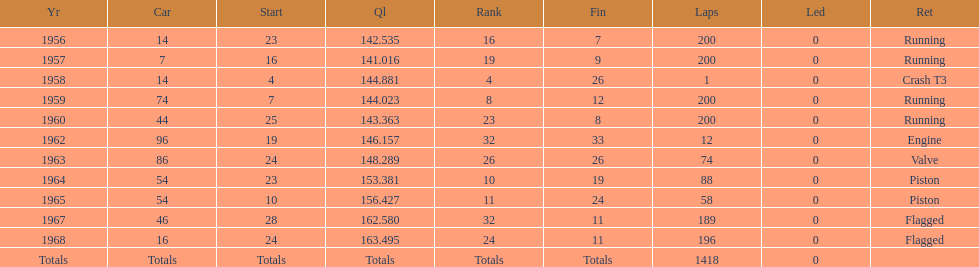What was its best starting position? 4. Give me the full table as a dictionary. {'header': ['Yr', 'Car', 'Start', 'Ql', 'Rank', 'Fin', 'Laps', 'Led', 'Ret'], 'rows': [['1956', '14', '23', '142.535', '16', '7', '200', '0', 'Running'], ['1957', '7', '16', '141.016', '19', '9', '200', '0', 'Running'], ['1958', '14', '4', '144.881', '4', '26', '1', '0', 'Crash T3'], ['1959', '74', '7', '144.023', '8', '12', '200', '0', 'Running'], ['1960', '44', '25', '143.363', '23', '8', '200', '0', 'Running'], ['1962', '96', '19', '146.157', '32', '33', '12', '0', 'Engine'], ['1963', '86', '24', '148.289', '26', '26', '74', '0', 'Valve'], ['1964', '54', '23', '153.381', '10', '19', '88', '0', 'Piston'], ['1965', '54', '10', '156.427', '11', '24', '58', '0', 'Piston'], ['1967', '46', '28', '162.580', '32', '11', '189', '0', 'Flagged'], ['1968', '16', '24', '163.495', '24', '11', '196', '0', 'Flagged'], ['Totals', 'Totals', 'Totals', 'Totals', 'Totals', 'Totals', '1418', '0', '']]} 